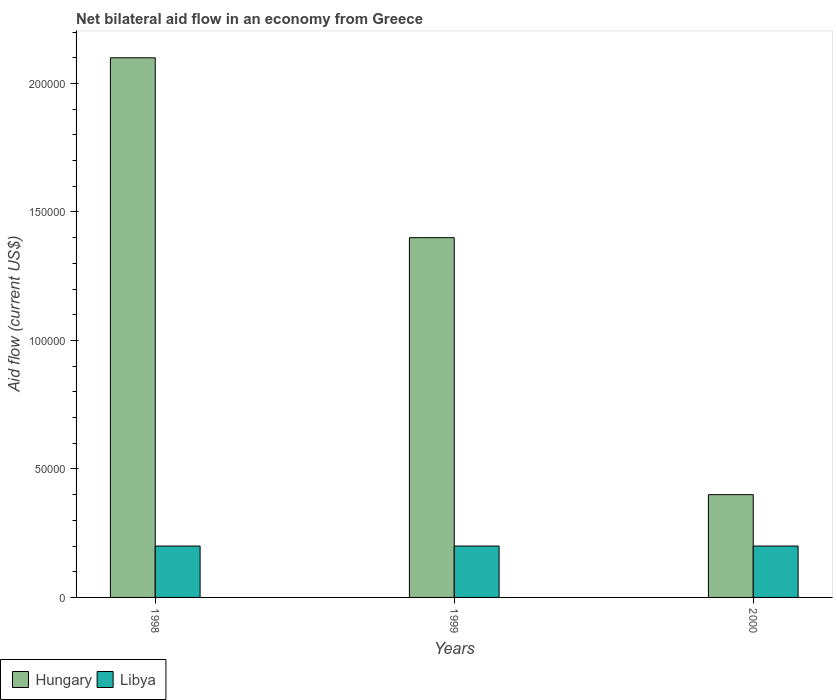How many different coloured bars are there?
Your answer should be very brief. 2. How many groups of bars are there?
Your answer should be compact. 3. Are the number of bars on each tick of the X-axis equal?
Give a very brief answer. Yes. How many bars are there on the 3rd tick from the right?
Give a very brief answer. 2. What is the label of the 3rd group of bars from the left?
Offer a terse response. 2000. In how many cases, is the number of bars for a given year not equal to the number of legend labels?
Offer a terse response. 0. What is the net bilateral aid flow in Hungary in 1998?
Provide a succinct answer. 2.10e+05. Across all years, what is the maximum net bilateral aid flow in Hungary?
Your answer should be very brief. 2.10e+05. In which year was the net bilateral aid flow in Libya maximum?
Provide a short and direct response. 1998. In which year was the net bilateral aid flow in Hungary minimum?
Provide a succinct answer. 2000. What is the total net bilateral aid flow in Libya in the graph?
Ensure brevity in your answer.  6.00e+04. What is the difference between the net bilateral aid flow in Libya in 1998 and that in 2000?
Keep it short and to the point. 0. What is the difference between the net bilateral aid flow in Hungary in 1998 and the net bilateral aid flow in Libya in 1999?
Your answer should be very brief. 1.90e+05. In the year 1999, what is the difference between the net bilateral aid flow in Hungary and net bilateral aid flow in Libya?
Offer a terse response. 1.20e+05. Is the net bilateral aid flow in Hungary in 1998 less than that in 1999?
Your answer should be very brief. No. In how many years, is the net bilateral aid flow in Libya greater than the average net bilateral aid flow in Libya taken over all years?
Offer a very short reply. 0. What does the 1st bar from the left in 2000 represents?
Offer a very short reply. Hungary. What does the 2nd bar from the right in 1998 represents?
Your answer should be very brief. Hungary. How many years are there in the graph?
Give a very brief answer. 3. Does the graph contain any zero values?
Provide a short and direct response. No. Does the graph contain grids?
Give a very brief answer. No. How are the legend labels stacked?
Provide a short and direct response. Horizontal. What is the title of the graph?
Keep it short and to the point. Net bilateral aid flow in an economy from Greece. Does "Japan" appear as one of the legend labels in the graph?
Ensure brevity in your answer.  No. What is the label or title of the X-axis?
Your response must be concise. Years. What is the label or title of the Y-axis?
Provide a succinct answer. Aid flow (current US$). What is the Aid flow (current US$) in Hungary in 1998?
Keep it short and to the point. 2.10e+05. What is the Aid flow (current US$) in Hungary in 1999?
Your response must be concise. 1.40e+05. What is the Aid flow (current US$) in Libya in 1999?
Your response must be concise. 2.00e+04. Across all years, what is the minimum Aid flow (current US$) in Libya?
Your response must be concise. 2.00e+04. What is the total Aid flow (current US$) of Hungary in the graph?
Your response must be concise. 3.90e+05. What is the difference between the Aid flow (current US$) of Hungary in 1998 and that in 1999?
Give a very brief answer. 7.00e+04. What is the difference between the Aid flow (current US$) in Libya in 1998 and that in 1999?
Your response must be concise. 0. What is the difference between the Aid flow (current US$) of Hungary in 1998 and that in 2000?
Provide a short and direct response. 1.70e+05. What is the difference between the Aid flow (current US$) in Libya in 1999 and that in 2000?
Offer a very short reply. 0. What is the difference between the Aid flow (current US$) in Hungary in 1998 and the Aid flow (current US$) in Libya in 1999?
Offer a terse response. 1.90e+05. What is the difference between the Aid flow (current US$) of Hungary in 1998 and the Aid flow (current US$) of Libya in 2000?
Your response must be concise. 1.90e+05. In the year 1999, what is the difference between the Aid flow (current US$) of Hungary and Aid flow (current US$) of Libya?
Provide a short and direct response. 1.20e+05. In the year 2000, what is the difference between the Aid flow (current US$) in Hungary and Aid flow (current US$) in Libya?
Ensure brevity in your answer.  2.00e+04. What is the ratio of the Aid flow (current US$) of Hungary in 1998 to that in 1999?
Your response must be concise. 1.5. What is the ratio of the Aid flow (current US$) in Libya in 1998 to that in 1999?
Provide a succinct answer. 1. What is the ratio of the Aid flow (current US$) in Hungary in 1998 to that in 2000?
Your response must be concise. 5.25. What is the ratio of the Aid flow (current US$) of Libya in 1998 to that in 2000?
Give a very brief answer. 1. What is the ratio of the Aid flow (current US$) in Hungary in 1999 to that in 2000?
Your answer should be compact. 3.5. What is the ratio of the Aid flow (current US$) in Libya in 1999 to that in 2000?
Your response must be concise. 1. What is the difference between the highest and the lowest Aid flow (current US$) of Libya?
Your answer should be compact. 0. 